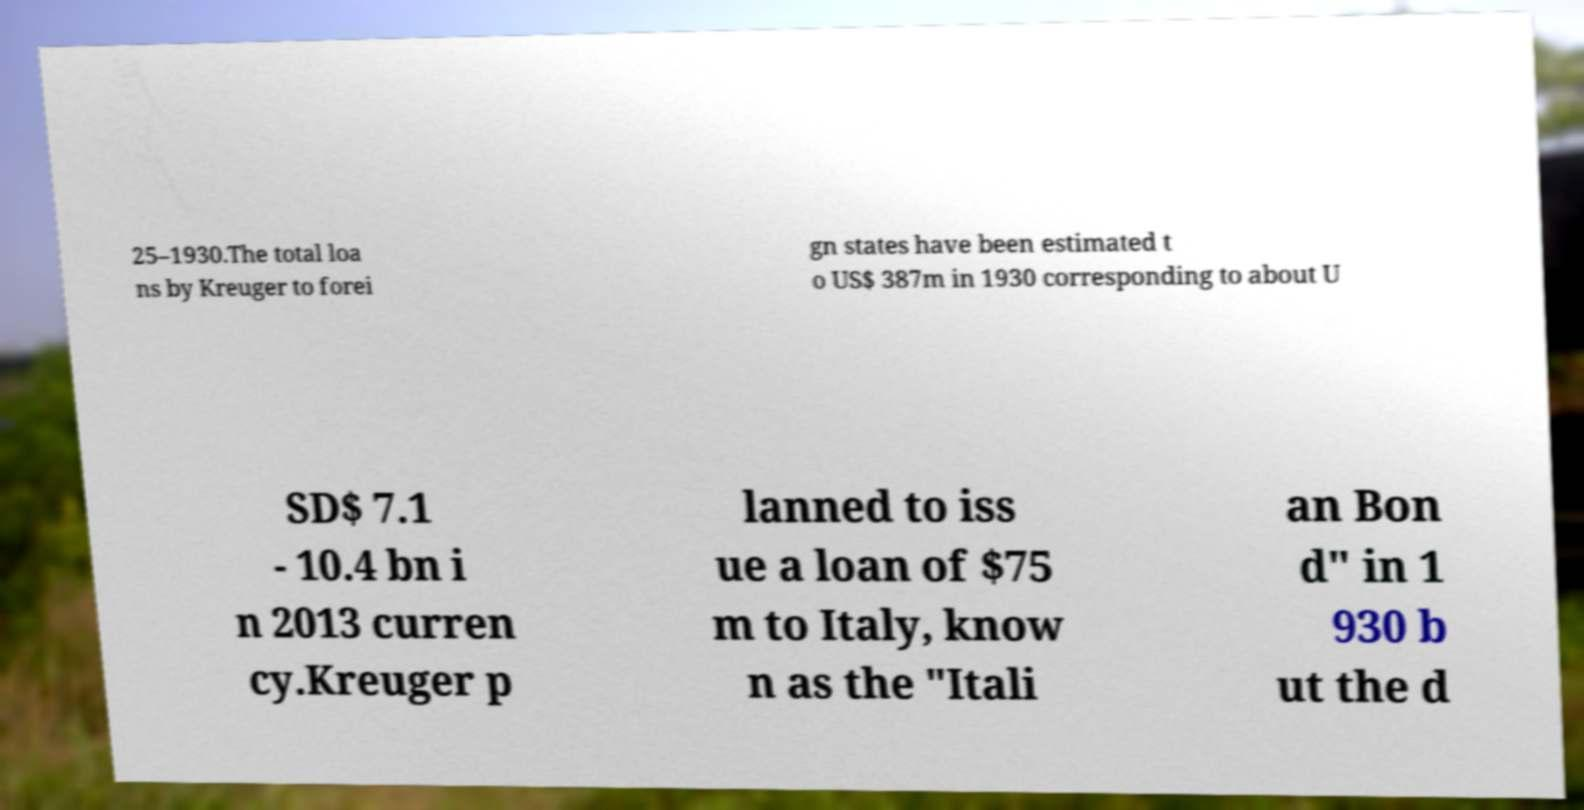What messages or text are displayed in this image? I need them in a readable, typed format. 25–1930.The total loa ns by Kreuger to forei gn states have been estimated t o US$ 387m in 1930 corresponding to about U SD$ 7.1 - 10.4 bn i n 2013 curren cy.Kreuger p lanned to iss ue a loan of $75 m to Italy, know n as the "Itali an Bon d" in 1 930 b ut the d 